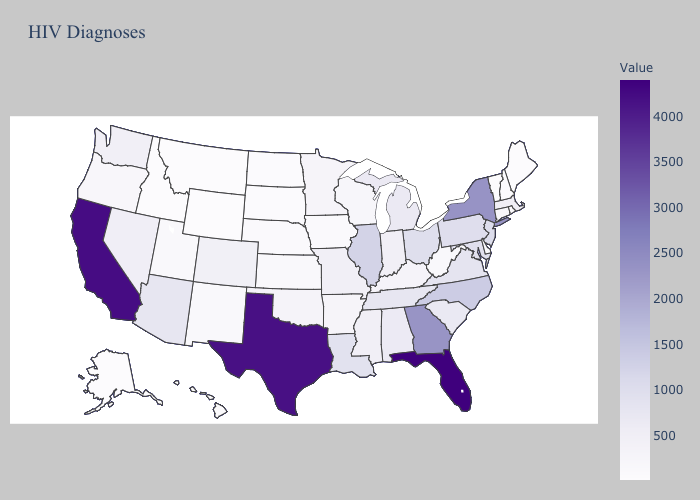Among the states that border Rhode Island , does Connecticut have the lowest value?
Be succinct. Yes. Does Illinois have the lowest value in the USA?
Answer briefly. No. Among the states that border Kentucky , does West Virginia have the lowest value?
Be succinct. Yes. Does California have the highest value in the West?
Short answer required. Yes. 